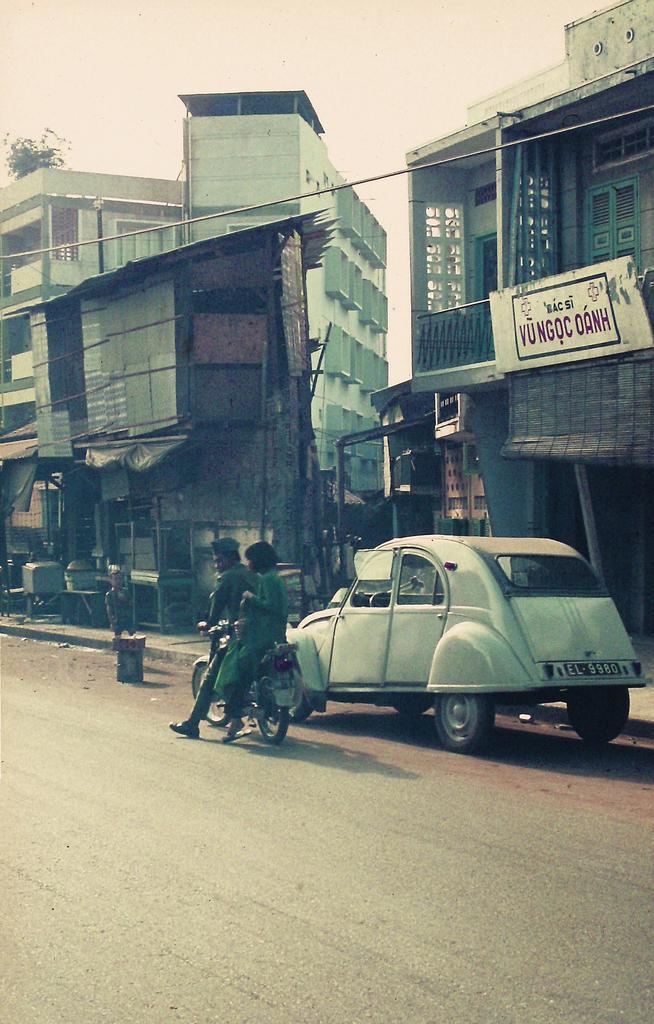How would you summarize this image in a sentence or two? On the right side there is a car, here a man is riding the bike. These are the houses, at the top it is the sky. 